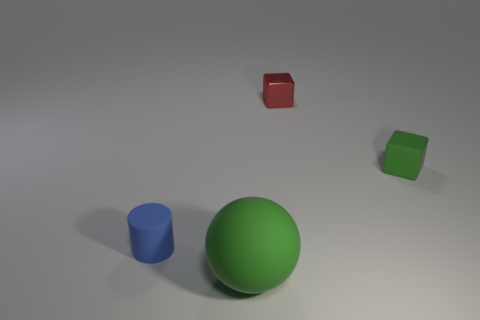There is a block that is the same size as the red metallic thing; what is its material?
Your answer should be very brief. Rubber. Is there any other thing that has the same size as the green rubber sphere?
Provide a succinct answer. No. What number of objects are either large cyan cylinders or matte objects that are behind the matte cylinder?
Provide a short and direct response. 1. The ball that is the same material as the tiny cylinder is what size?
Offer a terse response. Large. The green thing in front of the green rubber object that is to the right of the large sphere is what shape?
Provide a succinct answer. Sphere. There is a object that is behind the small blue cylinder and left of the tiny green thing; what size is it?
Offer a terse response. Small. Are there any other tiny green objects of the same shape as the tiny metal thing?
Your response must be concise. Yes. Is there anything else that has the same shape as the blue matte object?
Give a very brief answer. No. The green object that is on the left side of the green object that is on the right side of the thing in front of the cylinder is made of what material?
Your answer should be very brief. Rubber. Is there a green matte cube that has the same size as the red cube?
Ensure brevity in your answer.  Yes. 